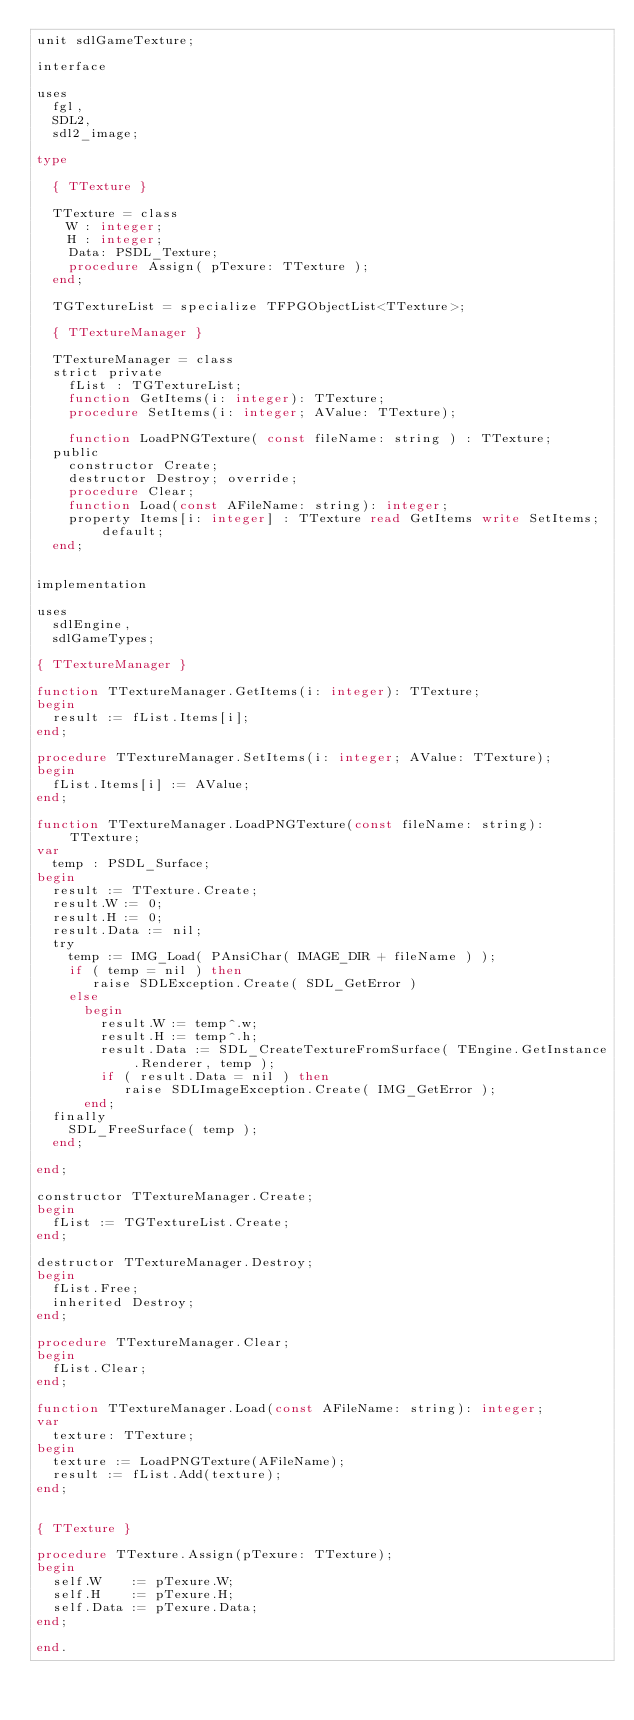<code> <loc_0><loc_0><loc_500><loc_500><_Pascal_>unit sdlGameTexture;

interface

uses
  fgl,
  SDL2,
  sdl2_image;

type

  { TTexture }

  TTexture = class
    W : integer;
    H : integer;
    Data: PSDL_Texture;
    procedure Assign( pTexure: TTexture );
  end;

  TGTextureList = specialize TFPGObjectList<TTexture>;

  { TTextureManager }

  TTextureManager = class
  strict private
    fList : TGTextureList;
    function GetItems(i: integer): TTexture;
    procedure SetItems(i: integer; AValue: TTexture);

    function LoadPNGTexture( const fileName: string ) : TTexture;
  public
    constructor Create;
    destructor Destroy; override;
    procedure Clear;
    function Load(const AFileName: string): integer;
    property Items[i: integer] : TTexture read GetItems write SetItems; default;
  end;


implementation

uses
  sdlEngine,
  sdlGameTypes;

{ TTextureManager }

function TTextureManager.GetItems(i: integer): TTexture;
begin
  result := fList.Items[i];
end;

procedure TTextureManager.SetItems(i: integer; AValue: TTexture);
begin
  fList.Items[i] := AValue;
end;

function TTextureManager.LoadPNGTexture(const fileName: string): TTexture;
var
  temp : PSDL_Surface;
begin
  result := TTexture.Create;
  result.W := 0;
  result.H := 0;
  result.Data := nil;
  try
    temp := IMG_Load( PAnsiChar( IMAGE_DIR + fileName ) );
    if ( temp = nil ) then
       raise SDLException.Create( SDL_GetError )
    else
      begin
        result.W := temp^.w;
        result.H := temp^.h;
        result.Data := SDL_CreateTextureFromSurface( TEngine.GetInstance.Renderer, temp );
        if ( result.Data = nil ) then
           raise SDLImageException.Create( IMG_GetError );
      end;
  finally
    SDL_FreeSurface( temp );
  end;

end;

constructor TTextureManager.Create;
begin
  fList := TGTextureList.Create;
end;

destructor TTextureManager.Destroy;
begin
  fList.Free;
  inherited Destroy;
end;

procedure TTextureManager.Clear;
begin
  fList.Clear;
end;

function TTextureManager.Load(const AFileName: string): integer;
var
  texture: TTexture;
begin
  texture := LoadPNGTexture(AFileName);
  result := fList.Add(texture);
end;


{ TTexture }

procedure TTexture.Assign(pTexure: TTexture);
begin
  self.W    := pTexure.W;
  self.H    := pTexure.H;
  self.Data := pTexure.Data;
end;

end.
</code> 